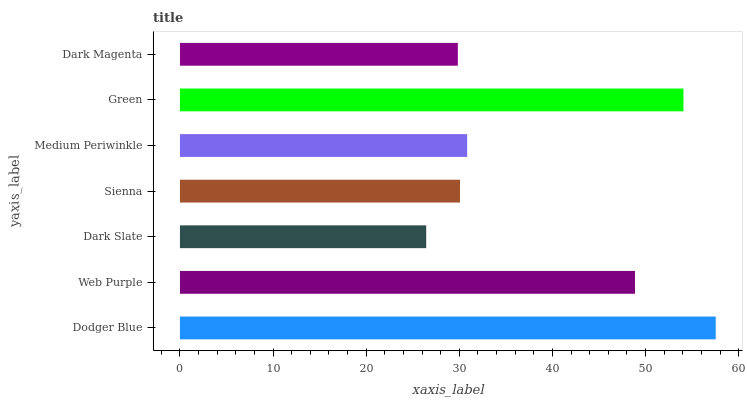Is Dark Slate the minimum?
Answer yes or no. Yes. Is Dodger Blue the maximum?
Answer yes or no. Yes. Is Web Purple the minimum?
Answer yes or no. No. Is Web Purple the maximum?
Answer yes or no. No. Is Dodger Blue greater than Web Purple?
Answer yes or no. Yes. Is Web Purple less than Dodger Blue?
Answer yes or no. Yes. Is Web Purple greater than Dodger Blue?
Answer yes or no. No. Is Dodger Blue less than Web Purple?
Answer yes or no. No. Is Medium Periwinkle the high median?
Answer yes or no. Yes. Is Medium Periwinkle the low median?
Answer yes or no. Yes. Is Dark Magenta the high median?
Answer yes or no. No. Is Dark Magenta the low median?
Answer yes or no. No. 